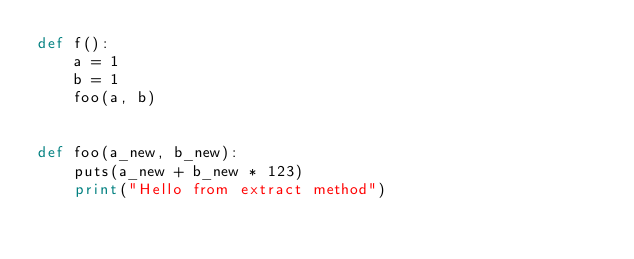Convert code to text. <code><loc_0><loc_0><loc_500><loc_500><_Python_>def f():
    a = 1
    b = 1
    foo(a, b)


def foo(a_new, b_new):
    puts(a_new + b_new * 123)
    print("Hello from extract method")

</code> 